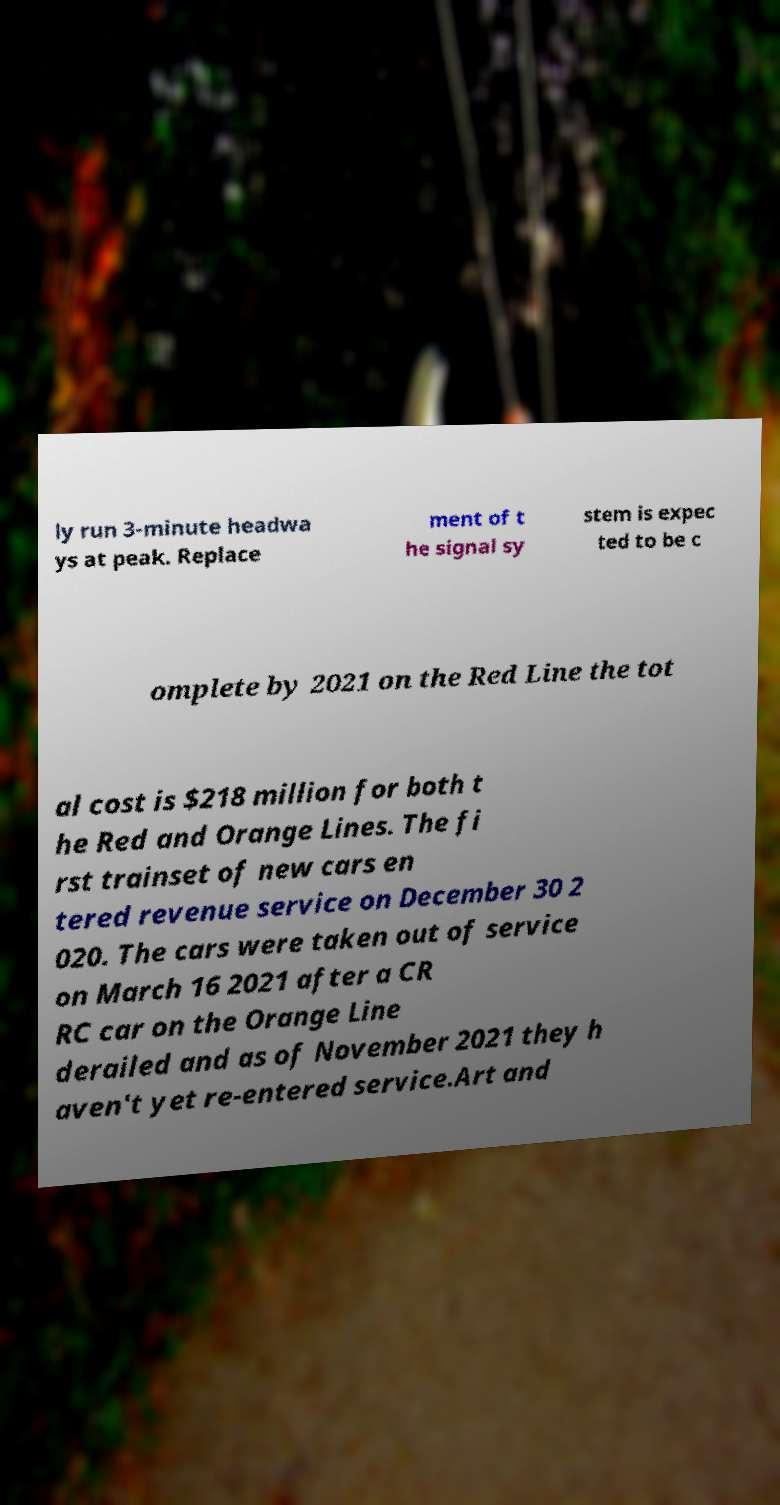Can you accurately transcribe the text from the provided image for me? ly run 3-minute headwa ys at peak. Replace ment of t he signal sy stem is expec ted to be c omplete by 2021 on the Red Line the tot al cost is $218 million for both t he Red and Orange Lines. The fi rst trainset of new cars en tered revenue service on December 30 2 020. The cars were taken out of service on March 16 2021 after a CR RC car on the Orange Line derailed and as of November 2021 they h aven't yet re-entered service.Art and 